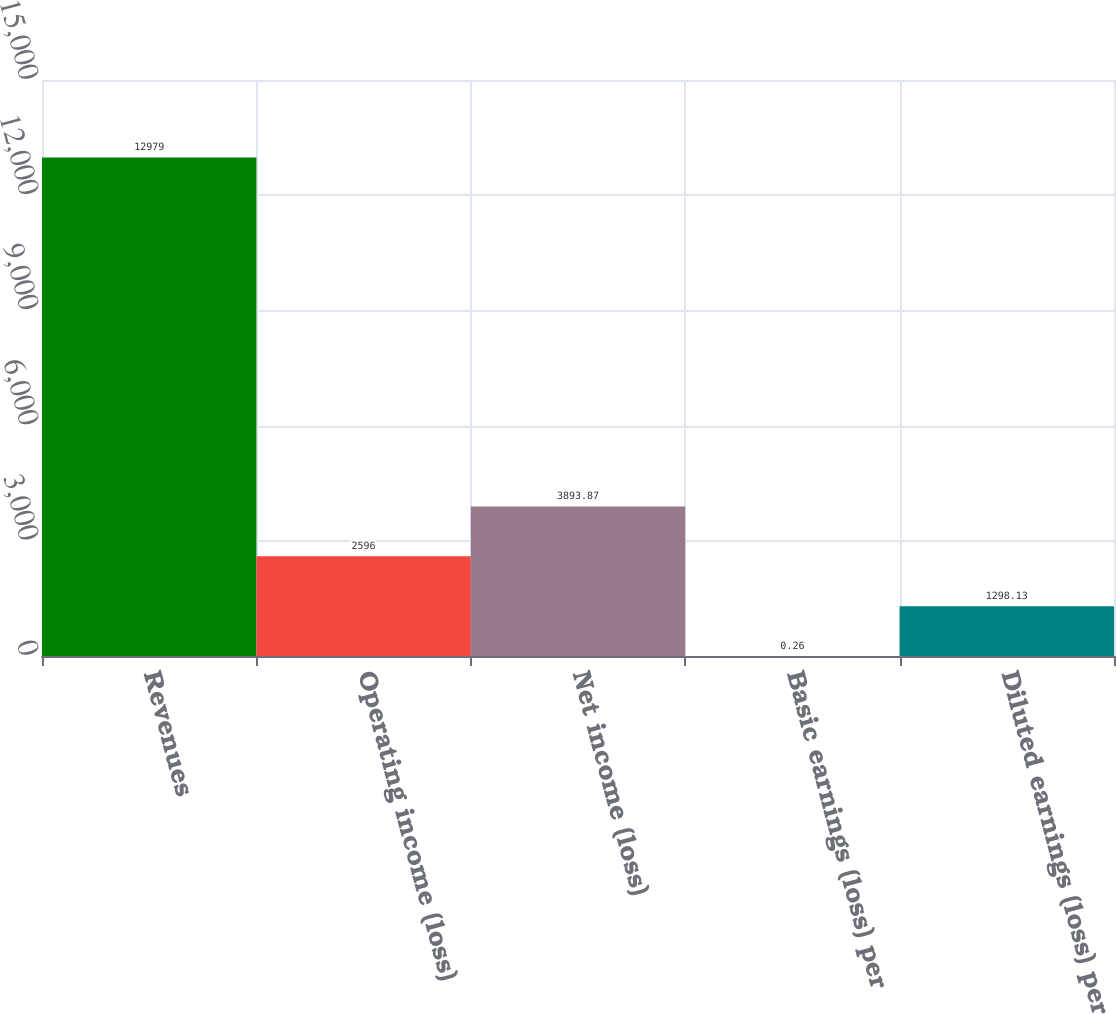Convert chart. <chart><loc_0><loc_0><loc_500><loc_500><bar_chart><fcel>Revenues<fcel>Operating income (loss)<fcel>Net income (loss)<fcel>Basic earnings (loss) per<fcel>Diluted earnings (loss) per<nl><fcel>12979<fcel>2596<fcel>3893.87<fcel>0.26<fcel>1298.13<nl></chart> 